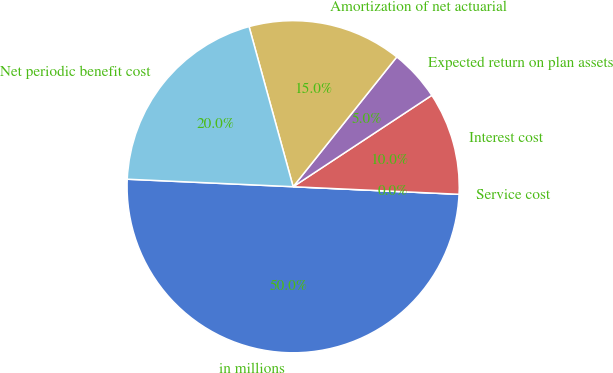Convert chart to OTSL. <chart><loc_0><loc_0><loc_500><loc_500><pie_chart><fcel>in millions<fcel>Service cost<fcel>Interest cost<fcel>Expected return on plan assets<fcel>Amortization of net actuarial<fcel>Net periodic benefit cost<nl><fcel>49.99%<fcel>0.0%<fcel>10.0%<fcel>5.0%<fcel>15.0%<fcel>20.0%<nl></chart> 